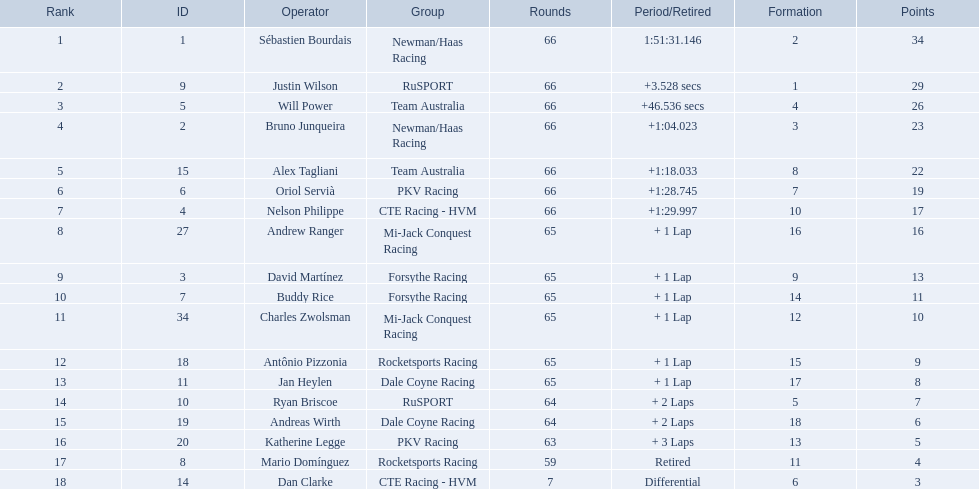How many points did first place receive? 34. How many did last place receive? 3. Who was the recipient of these last place points? Dan Clarke. 